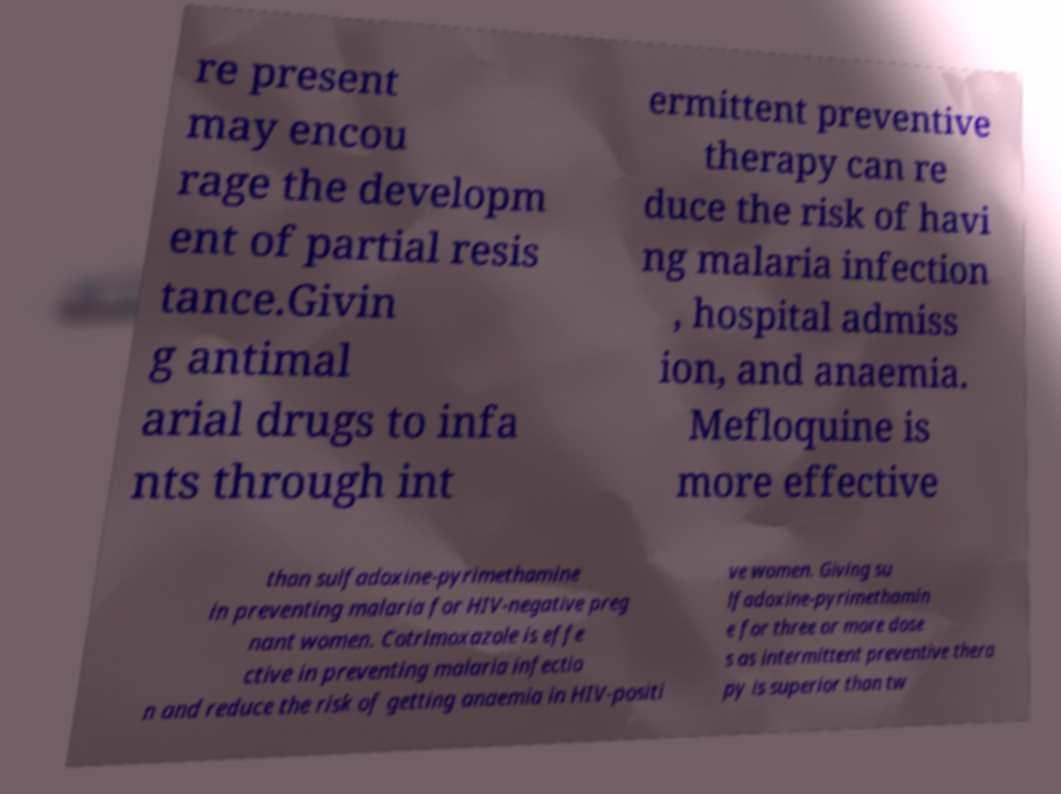Could you extract and type out the text from this image? re present may encou rage the developm ent of partial resis tance.Givin g antimal arial drugs to infa nts through int ermittent preventive therapy can re duce the risk of havi ng malaria infection , hospital admiss ion, and anaemia. Mefloquine is more effective than sulfadoxine-pyrimethamine in preventing malaria for HIV-negative preg nant women. Cotrimoxazole is effe ctive in preventing malaria infectio n and reduce the risk of getting anaemia in HIV-positi ve women. Giving su lfadoxine-pyrimethamin e for three or more dose s as intermittent preventive thera py is superior than tw 